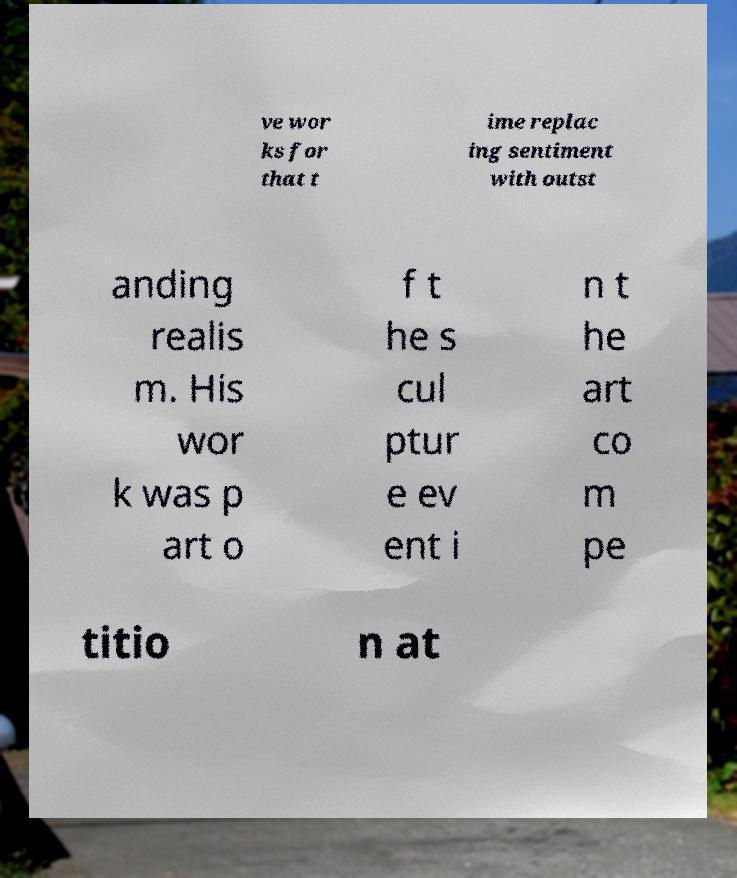Could you extract and type out the text from this image? ve wor ks for that t ime replac ing sentiment with outst anding realis m. His wor k was p art o f t he s cul ptur e ev ent i n t he art co m pe titio n at 